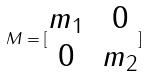Convert formula to latex. <formula><loc_0><loc_0><loc_500><loc_500>M = [ \begin{matrix} m _ { 1 } & 0 \\ 0 & m _ { 2 } \end{matrix} ]</formula> 